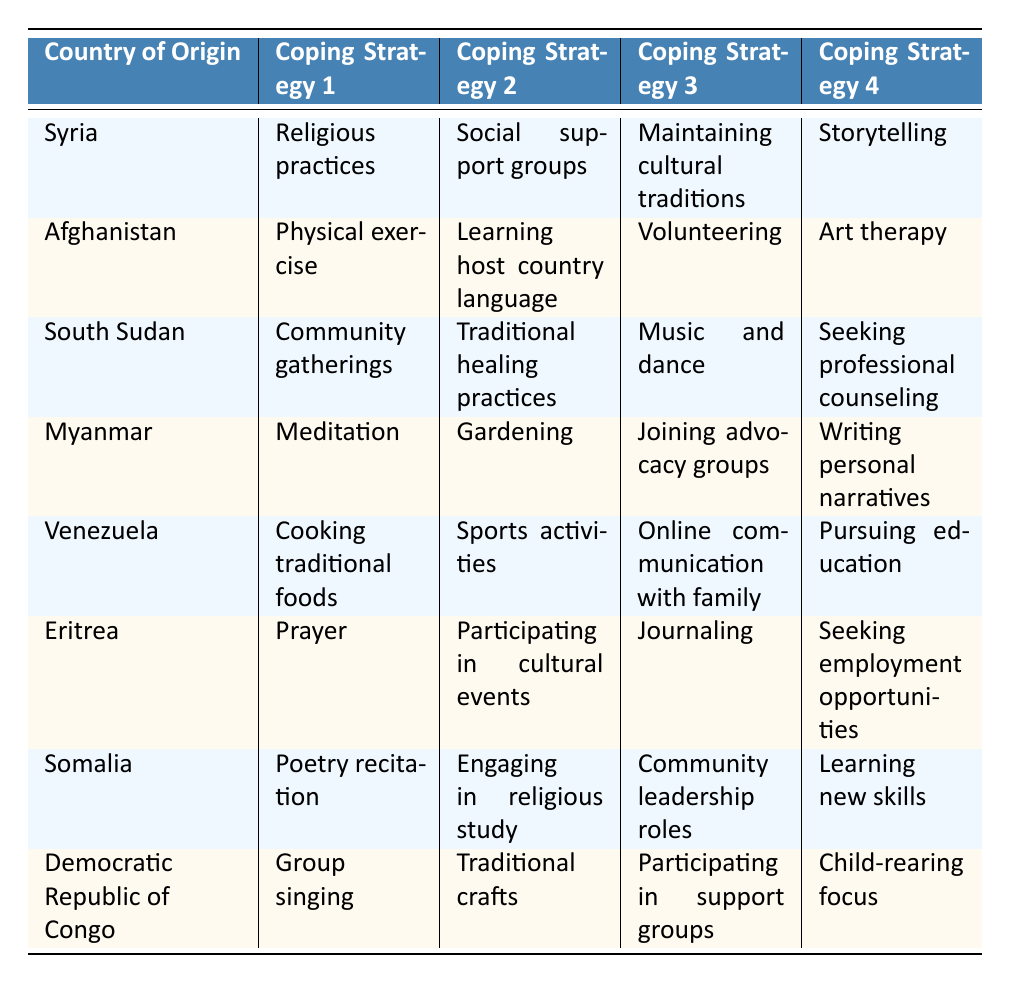What coping strategy is most commonly used by refugees from Syria? Referring to the table, the first coping strategy listed for Syria is "Religious practices."
Answer: Religious practices Which country of origin uses "Meditation" as a coping strategy? Looking at the table, "Meditation" is the first coping strategy listed for Myanmar.
Answer: Myanmar How many coping strategies are listed for each country? Each country in the table has four coping strategies listed beside it.
Answer: Four Is "Volunteering" a coping strategy for refugees from Afghanistan? According to the table, "Volunteering" is indeed noted as one of the coping strategies for Afghanistan.
Answer: Yes What is the least common strategy listed for South Sudan? The table shows four strategies for South Sudan; thus, there is no single "least common" strategy identified based on the provided data. Each is equally represented.
Answer: N/A Which country combines "Community gatherings" and "Traditional healing practices" in its coping strategies? The table indicates that both strategies are included for South Sudan.
Answer: South Sudan Which coping strategies are shared between refugees from Eritrea and those from Somalia? Analyzing both lists, there's no overlapping coping strategy; Eritreans use prayer and journaling while Somalis focus on poetry and religious study.
Answer: None What is the second coping strategy listed for Venezuela? The table lists "Sports activities" as the second coping strategy for Venezuela.
Answer: Sports activities How many countries listed use "Community support groups" as a coping strategy? The table shows that "Community support groups" is only listed under South Sudan and not present for any other country.
Answer: One Which coping strategy appears for refugees from most countries listed? Analyzing the table, it appears that no single coping strategy is repeated across multiple countries, each has unique strategies.
Answer: None 